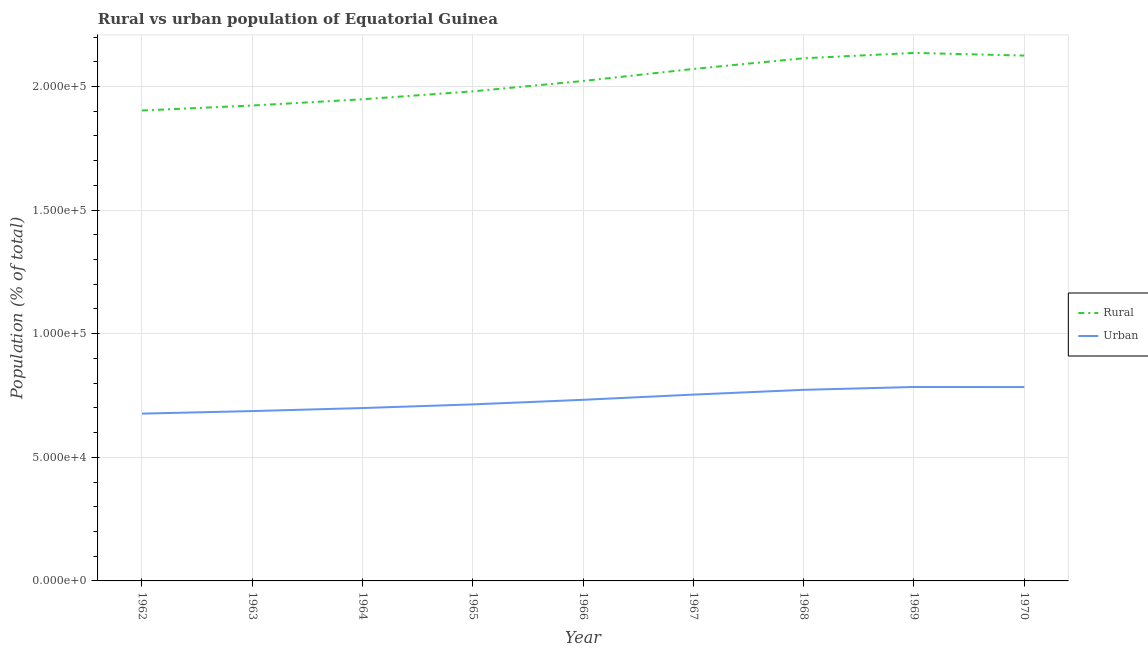How many different coloured lines are there?
Provide a succinct answer. 2. Does the line corresponding to rural population density intersect with the line corresponding to urban population density?
Provide a short and direct response. No. Is the number of lines equal to the number of legend labels?
Ensure brevity in your answer.  Yes. What is the urban population density in 1967?
Provide a short and direct response. 7.54e+04. Across all years, what is the maximum urban population density?
Ensure brevity in your answer.  7.84e+04. Across all years, what is the minimum urban population density?
Your answer should be very brief. 6.77e+04. In which year was the urban population density maximum?
Your response must be concise. 1969. In which year was the rural population density minimum?
Make the answer very short. 1962. What is the total rural population density in the graph?
Offer a very short reply. 1.82e+06. What is the difference between the rural population density in 1965 and that in 1969?
Your answer should be compact. -1.55e+04. What is the difference between the urban population density in 1969 and the rural population density in 1967?
Keep it short and to the point. -1.29e+05. What is the average rural population density per year?
Your response must be concise. 2.02e+05. In the year 1969, what is the difference between the urban population density and rural population density?
Provide a short and direct response. -1.35e+05. What is the ratio of the urban population density in 1967 to that in 1969?
Make the answer very short. 0.96. Is the rural population density in 1963 less than that in 1968?
Your answer should be compact. Yes. Is the difference between the rural population density in 1965 and 1966 greater than the difference between the urban population density in 1965 and 1966?
Provide a short and direct response. No. What is the difference between the highest and the second highest urban population density?
Provide a succinct answer. 33. What is the difference between the highest and the lowest urban population density?
Offer a very short reply. 1.08e+04. Does the urban population density monotonically increase over the years?
Offer a very short reply. No. Is the rural population density strictly greater than the urban population density over the years?
Make the answer very short. Yes. Is the urban population density strictly less than the rural population density over the years?
Keep it short and to the point. Yes. What is the difference between two consecutive major ticks on the Y-axis?
Provide a succinct answer. 5.00e+04. Does the graph contain grids?
Your response must be concise. Yes. Where does the legend appear in the graph?
Your answer should be compact. Center right. What is the title of the graph?
Your response must be concise. Rural vs urban population of Equatorial Guinea. What is the label or title of the X-axis?
Make the answer very short. Year. What is the label or title of the Y-axis?
Make the answer very short. Population (% of total). What is the Population (% of total) in Rural in 1962?
Provide a succinct answer. 1.90e+05. What is the Population (% of total) in Urban in 1962?
Give a very brief answer. 6.77e+04. What is the Population (% of total) in Rural in 1963?
Your response must be concise. 1.92e+05. What is the Population (% of total) of Urban in 1963?
Your answer should be very brief. 6.87e+04. What is the Population (% of total) of Rural in 1964?
Offer a terse response. 1.95e+05. What is the Population (% of total) in Urban in 1964?
Your answer should be very brief. 6.99e+04. What is the Population (% of total) in Rural in 1965?
Offer a terse response. 1.98e+05. What is the Population (% of total) in Urban in 1965?
Your answer should be compact. 7.14e+04. What is the Population (% of total) of Rural in 1966?
Give a very brief answer. 2.02e+05. What is the Population (% of total) in Urban in 1966?
Your answer should be very brief. 7.33e+04. What is the Population (% of total) of Rural in 1967?
Offer a terse response. 2.07e+05. What is the Population (% of total) in Urban in 1967?
Keep it short and to the point. 7.54e+04. What is the Population (% of total) in Rural in 1968?
Your response must be concise. 2.11e+05. What is the Population (% of total) of Urban in 1968?
Offer a terse response. 7.73e+04. What is the Population (% of total) in Rural in 1969?
Offer a very short reply. 2.14e+05. What is the Population (% of total) in Urban in 1969?
Offer a very short reply. 7.84e+04. What is the Population (% of total) in Rural in 1970?
Keep it short and to the point. 2.12e+05. What is the Population (% of total) of Urban in 1970?
Provide a succinct answer. 7.84e+04. Across all years, what is the maximum Population (% of total) of Rural?
Your answer should be compact. 2.14e+05. Across all years, what is the maximum Population (% of total) of Urban?
Offer a terse response. 7.84e+04. Across all years, what is the minimum Population (% of total) of Rural?
Provide a short and direct response. 1.90e+05. Across all years, what is the minimum Population (% of total) of Urban?
Ensure brevity in your answer.  6.77e+04. What is the total Population (% of total) of Rural in the graph?
Your response must be concise. 1.82e+06. What is the total Population (% of total) in Urban in the graph?
Make the answer very short. 6.60e+05. What is the difference between the Population (% of total) of Rural in 1962 and that in 1963?
Make the answer very short. -2018. What is the difference between the Population (% of total) in Urban in 1962 and that in 1963?
Your answer should be very brief. -1032. What is the difference between the Population (% of total) in Rural in 1962 and that in 1964?
Your answer should be compact. -4544. What is the difference between the Population (% of total) in Urban in 1962 and that in 1964?
Offer a terse response. -2259. What is the difference between the Population (% of total) in Rural in 1962 and that in 1965?
Ensure brevity in your answer.  -7751. What is the difference between the Population (% of total) in Urban in 1962 and that in 1965?
Make the answer very short. -3736. What is the difference between the Population (% of total) of Rural in 1962 and that in 1966?
Your answer should be compact. -1.19e+04. What is the difference between the Population (% of total) of Urban in 1962 and that in 1966?
Offer a very short reply. -5585. What is the difference between the Population (% of total) of Rural in 1962 and that in 1967?
Offer a very short reply. -1.68e+04. What is the difference between the Population (% of total) in Urban in 1962 and that in 1967?
Provide a succinct answer. -7694. What is the difference between the Population (% of total) in Rural in 1962 and that in 1968?
Offer a terse response. -2.11e+04. What is the difference between the Population (% of total) of Urban in 1962 and that in 1968?
Provide a succinct answer. -9626. What is the difference between the Population (% of total) in Rural in 1962 and that in 1969?
Provide a short and direct response. -2.33e+04. What is the difference between the Population (% of total) in Urban in 1962 and that in 1969?
Keep it short and to the point. -1.08e+04. What is the difference between the Population (% of total) in Rural in 1962 and that in 1970?
Make the answer very short. -2.22e+04. What is the difference between the Population (% of total) of Urban in 1962 and that in 1970?
Provide a short and direct response. -1.07e+04. What is the difference between the Population (% of total) of Rural in 1963 and that in 1964?
Provide a short and direct response. -2526. What is the difference between the Population (% of total) of Urban in 1963 and that in 1964?
Your answer should be very brief. -1227. What is the difference between the Population (% of total) in Rural in 1963 and that in 1965?
Your answer should be compact. -5733. What is the difference between the Population (% of total) of Urban in 1963 and that in 1965?
Your answer should be very brief. -2704. What is the difference between the Population (% of total) of Rural in 1963 and that in 1966?
Make the answer very short. -9927. What is the difference between the Population (% of total) in Urban in 1963 and that in 1966?
Your answer should be very brief. -4553. What is the difference between the Population (% of total) in Rural in 1963 and that in 1967?
Your answer should be very brief. -1.48e+04. What is the difference between the Population (% of total) of Urban in 1963 and that in 1967?
Your answer should be compact. -6662. What is the difference between the Population (% of total) of Rural in 1963 and that in 1968?
Keep it short and to the point. -1.91e+04. What is the difference between the Population (% of total) in Urban in 1963 and that in 1968?
Offer a very short reply. -8594. What is the difference between the Population (% of total) of Rural in 1963 and that in 1969?
Provide a short and direct response. -2.13e+04. What is the difference between the Population (% of total) of Urban in 1963 and that in 1969?
Provide a succinct answer. -9744. What is the difference between the Population (% of total) of Rural in 1963 and that in 1970?
Offer a terse response. -2.02e+04. What is the difference between the Population (% of total) in Urban in 1963 and that in 1970?
Offer a terse response. -9711. What is the difference between the Population (% of total) of Rural in 1964 and that in 1965?
Your answer should be very brief. -3207. What is the difference between the Population (% of total) in Urban in 1964 and that in 1965?
Your answer should be very brief. -1477. What is the difference between the Population (% of total) in Rural in 1964 and that in 1966?
Your answer should be compact. -7401. What is the difference between the Population (% of total) in Urban in 1964 and that in 1966?
Your answer should be compact. -3326. What is the difference between the Population (% of total) of Rural in 1964 and that in 1967?
Your answer should be compact. -1.23e+04. What is the difference between the Population (% of total) of Urban in 1964 and that in 1967?
Your response must be concise. -5435. What is the difference between the Population (% of total) of Rural in 1964 and that in 1968?
Your answer should be compact. -1.66e+04. What is the difference between the Population (% of total) in Urban in 1964 and that in 1968?
Keep it short and to the point. -7367. What is the difference between the Population (% of total) in Rural in 1964 and that in 1969?
Your response must be concise. -1.88e+04. What is the difference between the Population (% of total) in Urban in 1964 and that in 1969?
Make the answer very short. -8517. What is the difference between the Population (% of total) of Rural in 1964 and that in 1970?
Your response must be concise. -1.77e+04. What is the difference between the Population (% of total) of Urban in 1964 and that in 1970?
Make the answer very short. -8484. What is the difference between the Population (% of total) in Rural in 1965 and that in 1966?
Your answer should be very brief. -4194. What is the difference between the Population (% of total) of Urban in 1965 and that in 1966?
Your answer should be very brief. -1849. What is the difference between the Population (% of total) in Rural in 1965 and that in 1967?
Offer a very short reply. -9060. What is the difference between the Population (% of total) in Urban in 1965 and that in 1967?
Keep it short and to the point. -3958. What is the difference between the Population (% of total) in Rural in 1965 and that in 1968?
Give a very brief answer. -1.34e+04. What is the difference between the Population (% of total) of Urban in 1965 and that in 1968?
Your answer should be very brief. -5890. What is the difference between the Population (% of total) in Rural in 1965 and that in 1969?
Provide a succinct answer. -1.55e+04. What is the difference between the Population (% of total) in Urban in 1965 and that in 1969?
Offer a very short reply. -7040. What is the difference between the Population (% of total) in Rural in 1965 and that in 1970?
Ensure brevity in your answer.  -1.45e+04. What is the difference between the Population (% of total) in Urban in 1965 and that in 1970?
Ensure brevity in your answer.  -7007. What is the difference between the Population (% of total) of Rural in 1966 and that in 1967?
Provide a short and direct response. -4866. What is the difference between the Population (% of total) of Urban in 1966 and that in 1967?
Your response must be concise. -2109. What is the difference between the Population (% of total) in Rural in 1966 and that in 1968?
Keep it short and to the point. -9190. What is the difference between the Population (% of total) in Urban in 1966 and that in 1968?
Provide a succinct answer. -4041. What is the difference between the Population (% of total) in Rural in 1966 and that in 1969?
Your answer should be very brief. -1.14e+04. What is the difference between the Population (% of total) of Urban in 1966 and that in 1969?
Your answer should be compact. -5191. What is the difference between the Population (% of total) of Rural in 1966 and that in 1970?
Your response must be concise. -1.03e+04. What is the difference between the Population (% of total) of Urban in 1966 and that in 1970?
Ensure brevity in your answer.  -5158. What is the difference between the Population (% of total) of Rural in 1967 and that in 1968?
Make the answer very short. -4324. What is the difference between the Population (% of total) of Urban in 1967 and that in 1968?
Keep it short and to the point. -1932. What is the difference between the Population (% of total) of Rural in 1967 and that in 1969?
Make the answer very short. -6487. What is the difference between the Population (% of total) in Urban in 1967 and that in 1969?
Give a very brief answer. -3082. What is the difference between the Population (% of total) in Rural in 1967 and that in 1970?
Your response must be concise. -5411. What is the difference between the Population (% of total) of Urban in 1967 and that in 1970?
Provide a succinct answer. -3049. What is the difference between the Population (% of total) in Rural in 1968 and that in 1969?
Give a very brief answer. -2163. What is the difference between the Population (% of total) of Urban in 1968 and that in 1969?
Offer a terse response. -1150. What is the difference between the Population (% of total) in Rural in 1968 and that in 1970?
Offer a very short reply. -1087. What is the difference between the Population (% of total) in Urban in 1968 and that in 1970?
Provide a short and direct response. -1117. What is the difference between the Population (% of total) in Rural in 1969 and that in 1970?
Offer a very short reply. 1076. What is the difference between the Population (% of total) in Rural in 1962 and the Population (% of total) in Urban in 1963?
Provide a succinct answer. 1.22e+05. What is the difference between the Population (% of total) of Rural in 1962 and the Population (% of total) of Urban in 1964?
Ensure brevity in your answer.  1.20e+05. What is the difference between the Population (% of total) of Rural in 1962 and the Population (% of total) of Urban in 1965?
Give a very brief answer. 1.19e+05. What is the difference between the Population (% of total) in Rural in 1962 and the Population (% of total) in Urban in 1966?
Provide a succinct answer. 1.17e+05. What is the difference between the Population (% of total) of Rural in 1962 and the Population (% of total) of Urban in 1967?
Make the answer very short. 1.15e+05. What is the difference between the Population (% of total) in Rural in 1962 and the Population (% of total) in Urban in 1968?
Make the answer very short. 1.13e+05. What is the difference between the Population (% of total) in Rural in 1962 and the Population (% of total) in Urban in 1969?
Make the answer very short. 1.12e+05. What is the difference between the Population (% of total) of Rural in 1962 and the Population (% of total) of Urban in 1970?
Ensure brevity in your answer.  1.12e+05. What is the difference between the Population (% of total) in Rural in 1963 and the Population (% of total) in Urban in 1964?
Give a very brief answer. 1.22e+05. What is the difference between the Population (% of total) of Rural in 1963 and the Population (% of total) of Urban in 1965?
Provide a short and direct response. 1.21e+05. What is the difference between the Population (% of total) in Rural in 1963 and the Population (% of total) in Urban in 1966?
Your answer should be compact. 1.19e+05. What is the difference between the Population (% of total) in Rural in 1963 and the Population (% of total) in Urban in 1967?
Give a very brief answer. 1.17e+05. What is the difference between the Population (% of total) of Rural in 1963 and the Population (% of total) of Urban in 1968?
Provide a short and direct response. 1.15e+05. What is the difference between the Population (% of total) of Rural in 1963 and the Population (% of total) of Urban in 1969?
Provide a succinct answer. 1.14e+05. What is the difference between the Population (% of total) in Rural in 1963 and the Population (% of total) in Urban in 1970?
Your response must be concise. 1.14e+05. What is the difference between the Population (% of total) in Rural in 1964 and the Population (% of total) in Urban in 1965?
Your answer should be compact. 1.23e+05. What is the difference between the Population (% of total) in Rural in 1964 and the Population (% of total) in Urban in 1966?
Offer a terse response. 1.22e+05. What is the difference between the Population (% of total) in Rural in 1964 and the Population (% of total) in Urban in 1967?
Your response must be concise. 1.19e+05. What is the difference between the Population (% of total) in Rural in 1964 and the Population (% of total) in Urban in 1968?
Give a very brief answer. 1.18e+05. What is the difference between the Population (% of total) in Rural in 1964 and the Population (% of total) in Urban in 1969?
Your answer should be compact. 1.16e+05. What is the difference between the Population (% of total) of Rural in 1964 and the Population (% of total) of Urban in 1970?
Make the answer very short. 1.16e+05. What is the difference between the Population (% of total) of Rural in 1965 and the Population (% of total) of Urban in 1966?
Provide a succinct answer. 1.25e+05. What is the difference between the Population (% of total) of Rural in 1965 and the Population (% of total) of Urban in 1967?
Your answer should be very brief. 1.23e+05. What is the difference between the Population (% of total) in Rural in 1965 and the Population (% of total) in Urban in 1968?
Your response must be concise. 1.21e+05. What is the difference between the Population (% of total) in Rural in 1965 and the Population (% of total) in Urban in 1969?
Your answer should be compact. 1.20e+05. What is the difference between the Population (% of total) in Rural in 1965 and the Population (% of total) in Urban in 1970?
Your answer should be compact. 1.20e+05. What is the difference between the Population (% of total) in Rural in 1966 and the Population (% of total) in Urban in 1967?
Offer a very short reply. 1.27e+05. What is the difference between the Population (% of total) in Rural in 1966 and the Population (% of total) in Urban in 1968?
Offer a terse response. 1.25e+05. What is the difference between the Population (% of total) of Rural in 1966 and the Population (% of total) of Urban in 1969?
Ensure brevity in your answer.  1.24e+05. What is the difference between the Population (% of total) in Rural in 1966 and the Population (% of total) in Urban in 1970?
Your answer should be compact. 1.24e+05. What is the difference between the Population (% of total) of Rural in 1967 and the Population (% of total) of Urban in 1968?
Keep it short and to the point. 1.30e+05. What is the difference between the Population (% of total) of Rural in 1967 and the Population (% of total) of Urban in 1969?
Your answer should be very brief. 1.29e+05. What is the difference between the Population (% of total) of Rural in 1967 and the Population (% of total) of Urban in 1970?
Give a very brief answer. 1.29e+05. What is the difference between the Population (% of total) in Rural in 1968 and the Population (% of total) in Urban in 1969?
Your answer should be compact. 1.33e+05. What is the difference between the Population (% of total) of Rural in 1968 and the Population (% of total) of Urban in 1970?
Your response must be concise. 1.33e+05. What is the difference between the Population (% of total) of Rural in 1969 and the Population (% of total) of Urban in 1970?
Your answer should be compact. 1.35e+05. What is the average Population (% of total) in Rural per year?
Keep it short and to the point. 2.02e+05. What is the average Population (% of total) of Urban per year?
Provide a short and direct response. 7.34e+04. In the year 1962, what is the difference between the Population (% of total) of Rural and Population (% of total) of Urban?
Your answer should be compact. 1.23e+05. In the year 1963, what is the difference between the Population (% of total) of Rural and Population (% of total) of Urban?
Your answer should be very brief. 1.24e+05. In the year 1964, what is the difference between the Population (% of total) in Rural and Population (% of total) in Urban?
Keep it short and to the point. 1.25e+05. In the year 1965, what is the difference between the Population (% of total) in Rural and Population (% of total) in Urban?
Your answer should be compact. 1.27e+05. In the year 1966, what is the difference between the Population (% of total) in Rural and Population (% of total) in Urban?
Make the answer very short. 1.29e+05. In the year 1967, what is the difference between the Population (% of total) of Rural and Population (% of total) of Urban?
Provide a short and direct response. 1.32e+05. In the year 1968, what is the difference between the Population (% of total) in Rural and Population (% of total) in Urban?
Give a very brief answer. 1.34e+05. In the year 1969, what is the difference between the Population (% of total) of Rural and Population (% of total) of Urban?
Give a very brief answer. 1.35e+05. In the year 1970, what is the difference between the Population (% of total) in Rural and Population (% of total) in Urban?
Provide a short and direct response. 1.34e+05. What is the ratio of the Population (% of total) in Rural in 1962 to that in 1963?
Provide a short and direct response. 0.99. What is the ratio of the Population (% of total) in Urban in 1962 to that in 1963?
Offer a very short reply. 0.98. What is the ratio of the Population (% of total) of Rural in 1962 to that in 1964?
Your answer should be compact. 0.98. What is the ratio of the Population (% of total) in Rural in 1962 to that in 1965?
Offer a terse response. 0.96. What is the ratio of the Population (% of total) in Urban in 1962 to that in 1965?
Provide a short and direct response. 0.95. What is the ratio of the Population (% of total) in Rural in 1962 to that in 1966?
Your answer should be very brief. 0.94. What is the ratio of the Population (% of total) of Urban in 1962 to that in 1966?
Provide a succinct answer. 0.92. What is the ratio of the Population (% of total) of Rural in 1962 to that in 1967?
Your answer should be very brief. 0.92. What is the ratio of the Population (% of total) of Urban in 1962 to that in 1967?
Your answer should be very brief. 0.9. What is the ratio of the Population (% of total) in Urban in 1962 to that in 1968?
Your response must be concise. 0.88. What is the ratio of the Population (% of total) of Rural in 1962 to that in 1969?
Provide a short and direct response. 0.89. What is the ratio of the Population (% of total) in Urban in 1962 to that in 1969?
Provide a short and direct response. 0.86. What is the ratio of the Population (% of total) in Rural in 1962 to that in 1970?
Offer a terse response. 0.9. What is the ratio of the Population (% of total) in Urban in 1962 to that in 1970?
Provide a short and direct response. 0.86. What is the ratio of the Population (% of total) of Urban in 1963 to that in 1964?
Provide a succinct answer. 0.98. What is the ratio of the Population (% of total) of Rural in 1963 to that in 1965?
Make the answer very short. 0.97. What is the ratio of the Population (% of total) in Urban in 1963 to that in 1965?
Offer a very short reply. 0.96. What is the ratio of the Population (% of total) of Rural in 1963 to that in 1966?
Keep it short and to the point. 0.95. What is the ratio of the Population (% of total) in Urban in 1963 to that in 1966?
Your answer should be very brief. 0.94. What is the ratio of the Population (% of total) in Rural in 1963 to that in 1967?
Offer a terse response. 0.93. What is the ratio of the Population (% of total) in Urban in 1963 to that in 1967?
Your answer should be very brief. 0.91. What is the ratio of the Population (% of total) of Rural in 1963 to that in 1968?
Make the answer very short. 0.91. What is the ratio of the Population (% of total) of Urban in 1963 to that in 1968?
Offer a very short reply. 0.89. What is the ratio of the Population (% of total) of Rural in 1963 to that in 1969?
Offer a very short reply. 0.9. What is the ratio of the Population (% of total) in Urban in 1963 to that in 1969?
Offer a terse response. 0.88. What is the ratio of the Population (% of total) of Rural in 1963 to that in 1970?
Provide a short and direct response. 0.9. What is the ratio of the Population (% of total) of Urban in 1963 to that in 1970?
Your answer should be compact. 0.88. What is the ratio of the Population (% of total) in Rural in 1964 to that in 1965?
Ensure brevity in your answer.  0.98. What is the ratio of the Population (% of total) in Urban in 1964 to that in 1965?
Give a very brief answer. 0.98. What is the ratio of the Population (% of total) in Rural in 1964 to that in 1966?
Your response must be concise. 0.96. What is the ratio of the Population (% of total) of Urban in 1964 to that in 1966?
Your response must be concise. 0.95. What is the ratio of the Population (% of total) of Rural in 1964 to that in 1967?
Keep it short and to the point. 0.94. What is the ratio of the Population (% of total) of Urban in 1964 to that in 1967?
Ensure brevity in your answer.  0.93. What is the ratio of the Population (% of total) in Rural in 1964 to that in 1968?
Keep it short and to the point. 0.92. What is the ratio of the Population (% of total) of Urban in 1964 to that in 1968?
Provide a succinct answer. 0.9. What is the ratio of the Population (% of total) in Rural in 1964 to that in 1969?
Keep it short and to the point. 0.91. What is the ratio of the Population (% of total) in Urban in 1964 to that in 1969?
Your answer should be very brief. 0.89. What is the ratio of the Population (% of total) of Rural in 1964 to that in 1970?
Offer a terse response. 0.92. What is the ratio of the Population (% of total) of Urban in 1964 to that in 1970?
Keep it short and to the point. 0.89. What is the ratio of the Population (% of total) in Rural in 1965 to that in 1966?
Keep it short and to the point. 0.98. What is the ratio of the Population (% of total) in Urban in 1965 to that in 1966?
Provide a succinct answer. 0.97. What is the ratio of the Population (% of total) of Rural in 1965 to that in 1967?
Keep it short and to the point. 0.96. What is the ratio of the Population (% of total) in Urban in 1965 to that in 1967?
Provide a succinct answer. 0.95. What is the ratio of the Population (% of total) in Rural in 1965 to that in 1968?
Make the answer very short. 0.94. What is the ratio of the Population (% of total) of Urban in 1965 to that in 1968?
Ensure brevity in your answer.  0.92. What is the ratio of the Population (% of total) in Rural in 1965 to that in 1969?
Your response must be concise. 0.93. What is the ratio of the Population (% of total) of Urban in 1965 to that in 1969?
Offer a terse response. 0.91. What is the ratio of the Population (% of total) in Rural in 1965 to that in 1970?
Provide a succinct answer. 0.93. What is the ratio of the Population (% of total) in Urban in 1965 to that in 1970?
Your answer should be compact. 0.91. What is the ratio of the Population (% of total) of Rural in 1966 to that in 1967?
Your answer should be compact. 0.98. What is the ratio of the Population (% of total) in Rural in 1966 to that in 1968?
Make the answer very short. 0.96. What is the ratio of the Population (% of total) of Urban in 1966 to that in 1968?
Offer a very short reply. 0.95. What is the ratio of the Population (% of total) in Rural in 1966 to that in 1969?
Offer a terse response. 0.95. What is the ratio of the Population (% of total) in Urban in 1966 to that in 1969?
Keep it short and to the point. 0.93. What is the ratio of the Population (% of total) of Rural in 1966 to that in 1970?
Your answer should be compact. 0.95. What is the ratio of the Population (% of total) of Urban in 1966 to that in 1970?
Provide a succinct answer. 0.93. What is the ratio of the Population (% of total) of Rural in 1967 to that in 1968?
Your response must be concise. 0.98. What is the ratio of the Population (% of total) of Rural in 1967 to that in 1969?
Your answer should be compact. 0.97. What is the ratio of the Population (% of total) of Urban in 1967 to that in 1969?
Keep it short and to the point. 0.96. What is the ratio of the Population (% of total) of Rural in 1967 to that in 1970?
Ensure brevity in your answer.  0.97. What is the ratio of the Population (% of total) of Urban in 1967 to that in 1970?
Give a very brief answer. 0.96. What is the ratio of the Population (% of total) in Rural in 1968 to that in 1969?
Give a very brief answer. 0.99. What is the ratio of the Population (% of total) of Urban in 1968 to that in 1969?
Offer a terse response. 0.99. What is the ratio of the Population (% of total) in Urban in 1968 to that in 1970?
Offer a very short reply. 0.99. What is the ratio of the Population (% of total) in Urban in 1969 to that in 1970?
Provide a succinct answer. 1. What is the difference between the highest and the second highest Population (% of total) of Rural?
Offer a very short reply. 1076. What is the difference between the highest and the lowest Population (% of total) in Rural?
Keep it short and to the point. 2.33e+04. What is the difference between the highest and the lowest Population (% of total) of Urban?
Provide a short and direct response. 1.08e+04. 